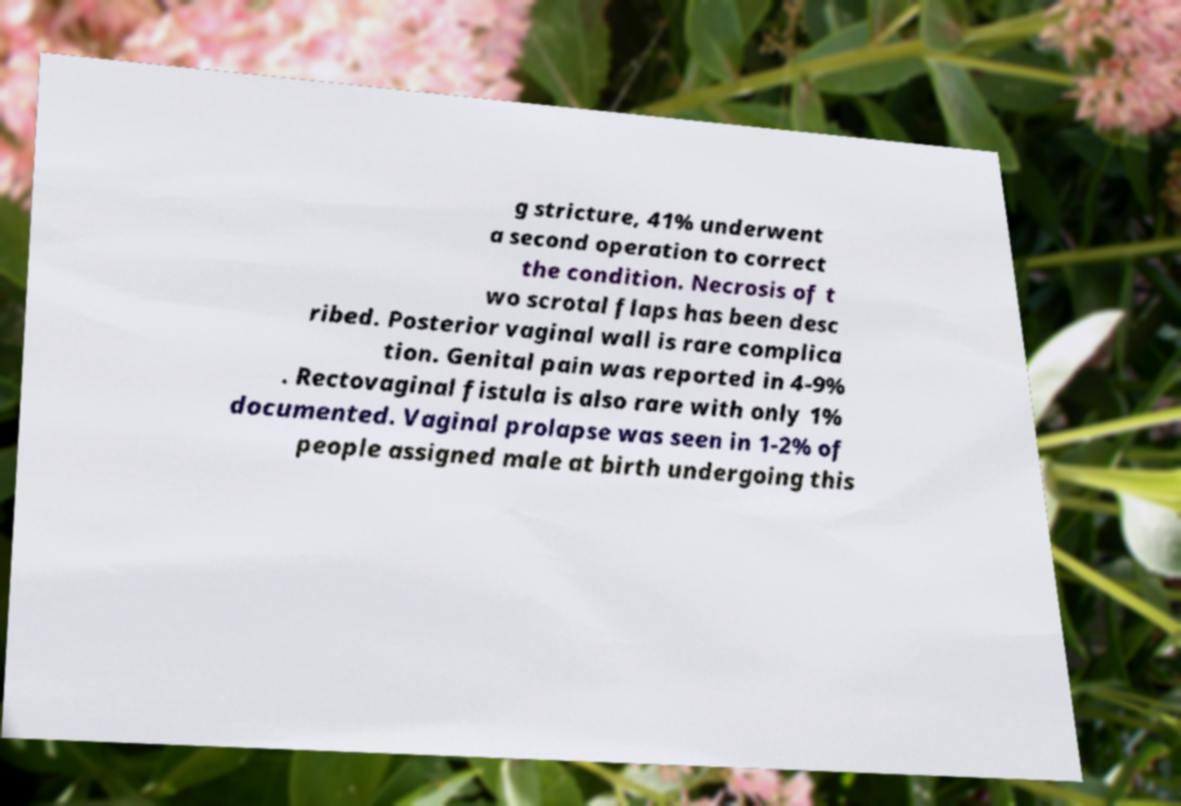I need the written content from this picture converted into text. Can you do that? g stricture, 41% underwent a second operation to correct the condition. Necrosis of t wo scrotal flaps has been desc ribed. Posterior vaginal wall is rare complica tion. Genital pain was reported in 4-9% . Rectovaginal fistula is also rare with only 1% documented. Vaginal prolapse was seen in 1-2% of people assigned male at birth undergoing this 